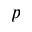<formula> <loc_0><loc_0><loc_500><loc_500>p</formula> 